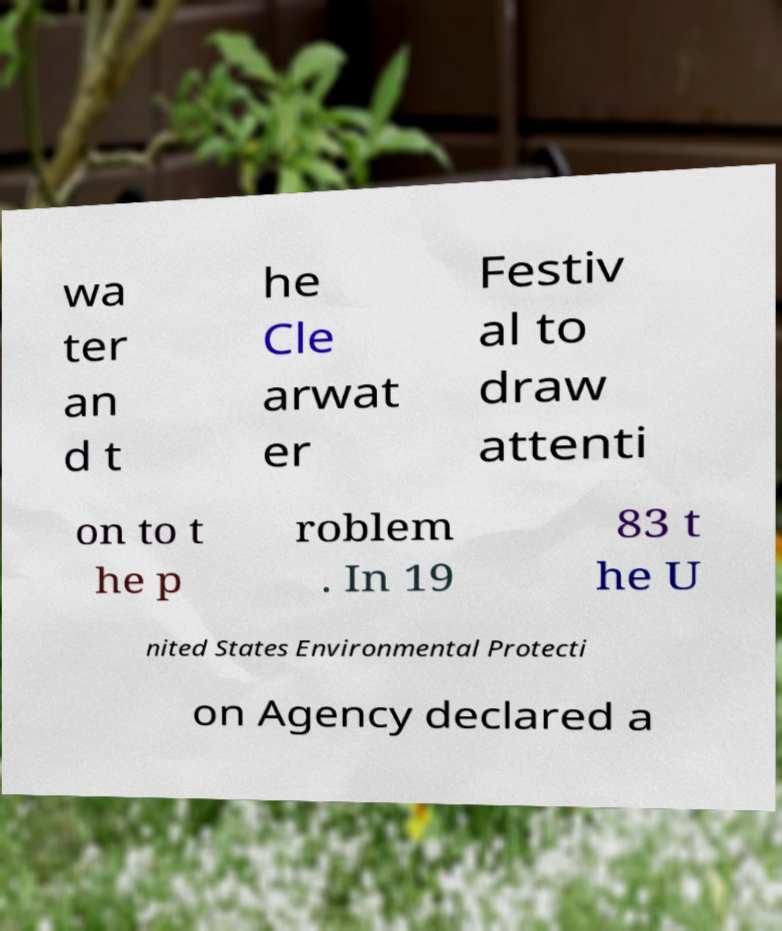Could you assist in decoding the text presented in this image and type it out clearly? wa ter an d t he Cle arwat er Festiv al to draw attenti on to t he p roblem . In 19 83 t he U nited States Environmental Protecti on Agency declared a 